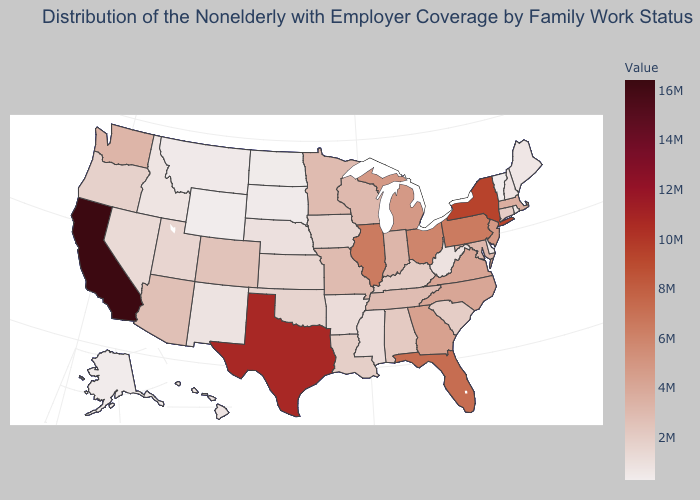Does the map have missing data?
Give a very brief answer. No. Does Idaho have a lower value than Ohio?
Be succinct. Yes. Is the legend a continuous bar?
Be succinct. Yes. Does Kentucky have the lowest value in the USA?
Short answer required. No. Among the states that border Nebraska , which have the lowest value?
Give a very brief answer. Wyoming. Does Vermont have the lowest value in the USA?
Short answer required. Yes. Does the map have missing data?
Answer briefly. No. 